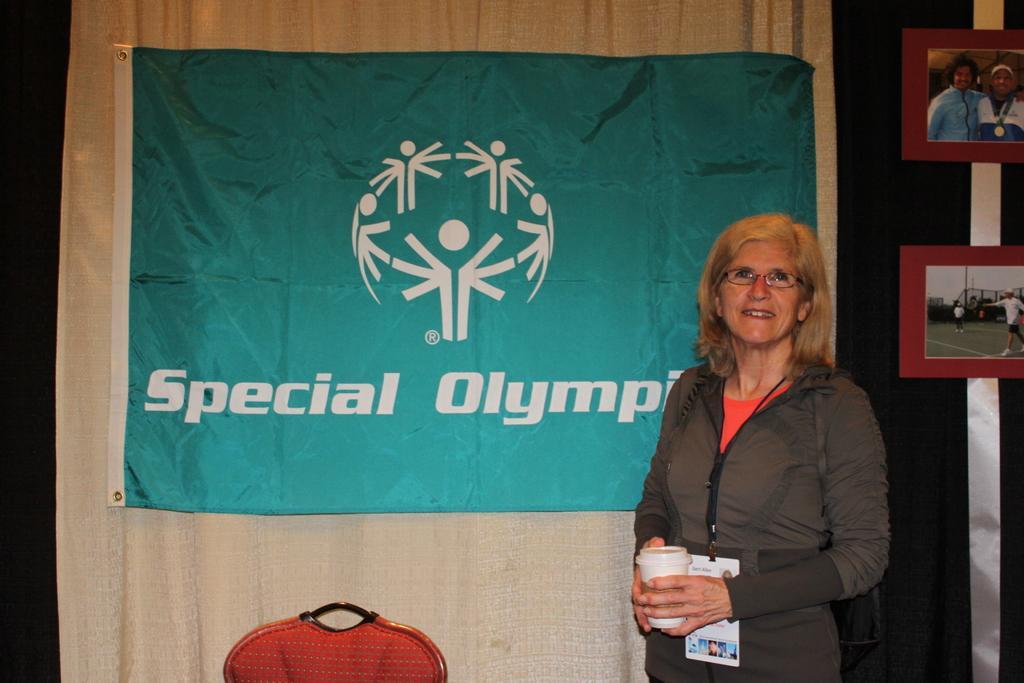Please provide a concise description of this image. A woman standing looking straight and smiling. She has short hair and wears spectacles. She wears a brown coat and holds a coffee cup. There is a banner with the name Special Olympic on it. There is a chair beside the woman. There are two photographs behind her. 